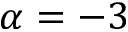Convert formula to latex. <formula><loc_0><loc_0><loc_500><loc_500>\alpha = - 3</formula> 